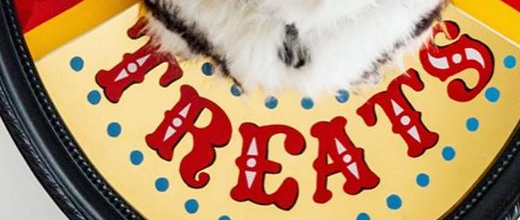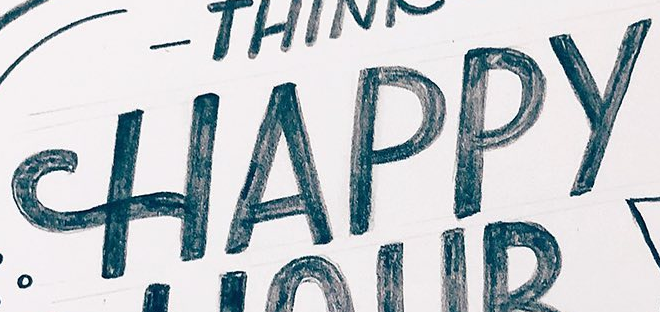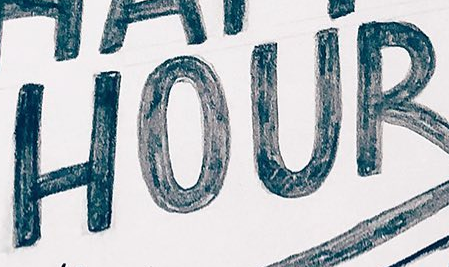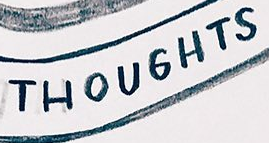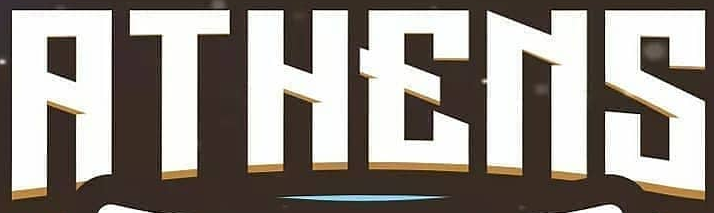What text appears in these images from left to right, separated by a semicolon? TREATS; HAPPY; HOUR; THOUGHTS; RTHENS 